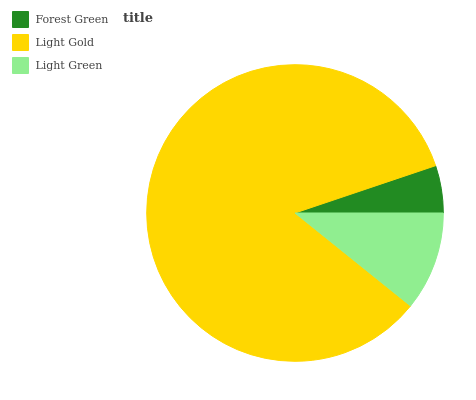Is Forest Green the minimum?
Answer yes or no. Yes. Is Light Gold the maximum?
Answer yes or no. Yes. Is Light Green the minimum?
Answer yes or no. No. Is Light Green the maximum?
Answer yes or no. No. Is Light Gold greater than Light Green?
Answer yes or no. Yes. Is Light Green less than Light Gold?
Answer yes or no. Yes. Is Light Green greater than Light Gold?
Answer yes or no. No. Is Light Gold less than Light Green?
Answer yes or no. No. Is Light Green the high median?
Answer yes or no. Yes. Is Light Green the low median?
Answer yes or no. Yes. Is Light Gold the high median?
Answer yes or no. No. Is Light Gold the low median?
Answer yes or no. No. 